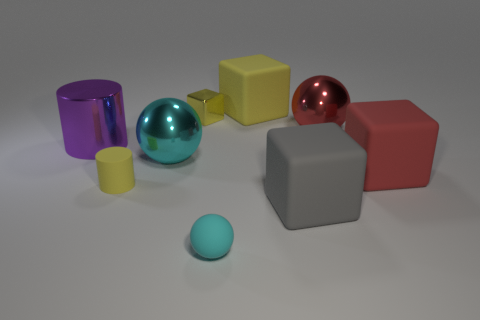There is a cube that is left of the tiny matte thing that is right of the tiny metallic object; how big is it?
Your answer should be compact. Small. Is the number of big gray cubes less than the number of big red things?
Offer a terse response. Yes. What material is the large object that is both on the right side of the large gray rubber thing and to the left of the big red rubber object?
Your answer should be very brief. Metal. Is there a object in front of the matte cube behind the big purple shiny cylinder?
Keep it short and to the point. Yes. How many objects are either metal blocks or big red spheres?
Keep it short and to the point. 2. What is the shape of the large shiny object that is both behind the cyan shiny sphere and left of the gray rubber object?
Give a very brief answer. Cylinder. Are the tiny object behind the big purple metal object and the small sphere made of the same material?
Provide a succinct answer. No. What number of objects are either shiny blocks or yellow things behind the big red sphere?
Offer a terse response. 2. There is a cylinder that is the same material as the big red block; what is its color?
Provide a short and direct response. Yellow. What number of blue blocks are made of the same material as the large gray object?
Ensure brevity in your answer.  0. 